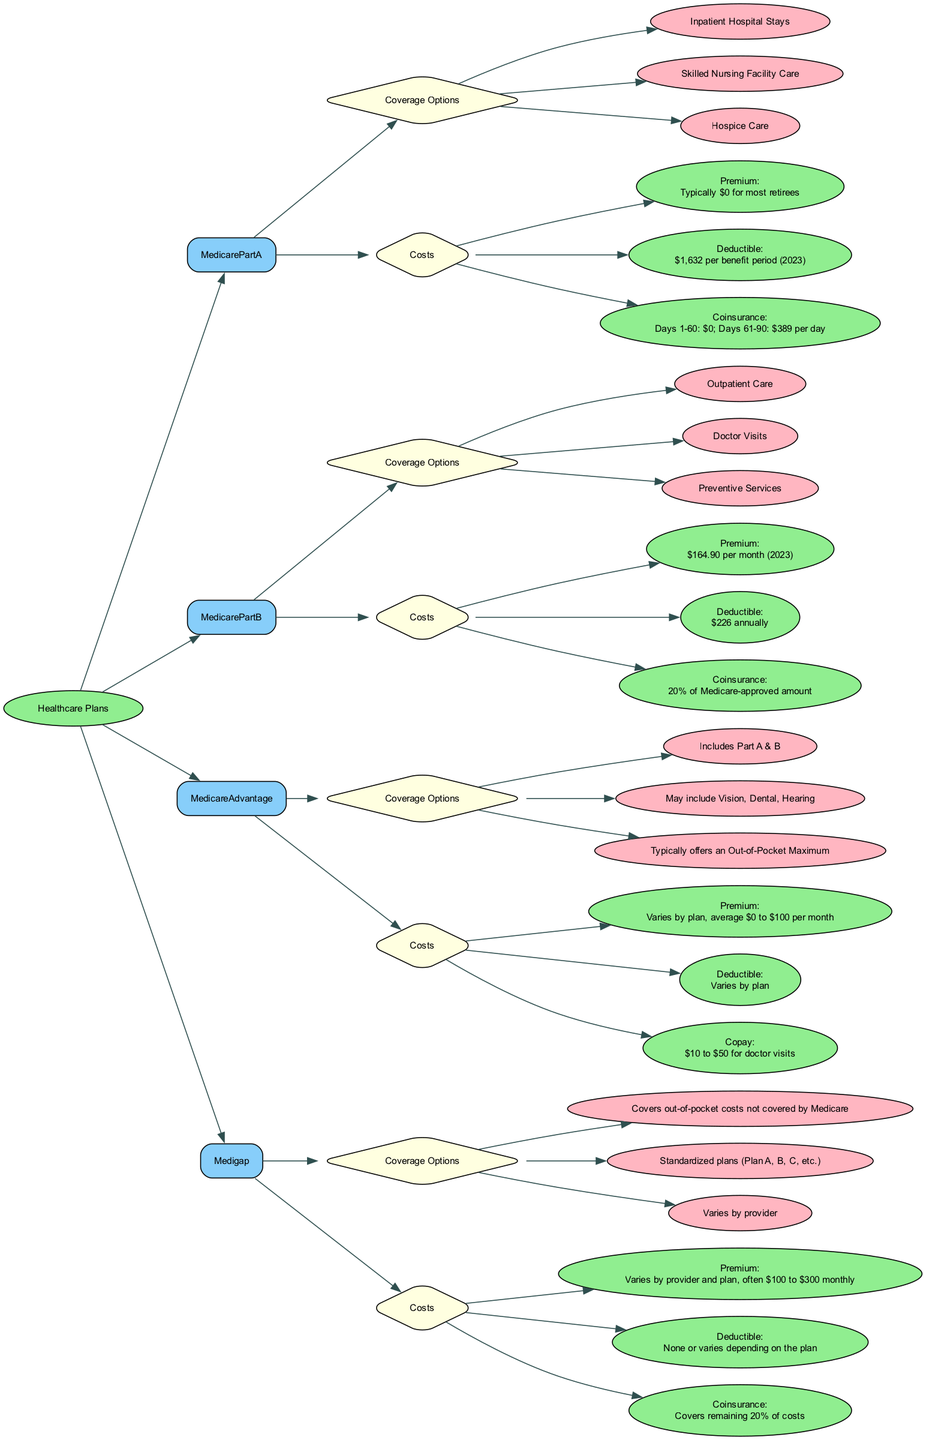What coverage options are included in Medicare Part A? The diagram lists the coverage options under the Medicare Part A node. These options are: Inpatient Hospital Stays, Skilled Nursing Facility Care, and Hospice Care.
Answer: Inpatient Hospital Stays, Skilled Nursing Facility Care, Hospice Care What is the premium for Medicare Part B? By examining the Medicare Part B costs node in the diagram, the premium amount is clearly stated as $164.90 per month for 2023.
Answer: $164.90 per month Which healthcare plan typically offers an out-of-pocket maximum? The diagram shows that Medicare Advantage includes Part A and B, along with a note stating "Typically offers an Out-of-Pocket Maximum". Therefore, it is the plan that typically provides this feature.
Answer: Medicare Advantage What is the deductible amount for Medigap? The Medigap costs node indicates that the deductible "None or varies depending on the plan". This means there isn't a strict value associated universally, but it can differ based on the selected plan.
Answer: None or varies How many coverage options does Medicare Advantage offer? The Medicare Advantage coverage options node lists three specific entries: Includes Part A & B, May include Vision, Dental, Hearing, and Typically offers an Out-of-Pocket Maximum. Counting these shows that there are three distinct coverage options.
Answer: 3 What is the coinsurance percentage for Medicare Part B? Looking at the costs associated with Medicare Part B, the coinsurance is stated to be 20% of Medicare-approved amount. This indicates the percentage those covered under this plan are expected to pay.
Answer: 20% Which healthcare plan has coverage for out-of-pocket costs not covered by Medicare? In the diagram, the coverage options under Medigap are specifically mentioned as covering out-of-pocket costs not covered by Medicare, identifying Medigap as the plan with this particular coverage.
Answer: Medigap What is the typical premium range for Medigap plans? The Medigap costs node specifies that the premium varies by provider and plan but is generally $100 to $300 monthly. This provides a range rather than a specific value.
Answer: $100 to $300 monthly What coverage option is unique to Medicare Advantage? The diagram outlines that Medicare Advantage may include Vision, Dental, and Hearing. These options are distinctive to this plan, indicating the added benefits beyond the standard Medicare coverage.
Answer: Vision, Dental, Hearing 